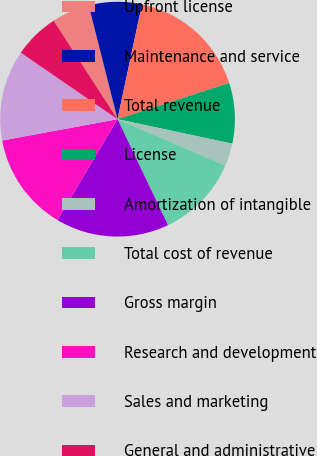<chart> <loc_0><loc_0><loc_500><loc_500><pie_chart><fcel>Upfront license<fcel>Maintenance and service<fcel>Total revenue<fcel>License<fcel>Amortization of intangible<fcel>Total cost of revenue<fcel>Gross margin<fcel>Research and development<fcel>Sales and marketing<fcel>General and administrative<nl><fcel>5.21%<fcel>7.29%<fcel>16.67%<fcel>8.33%<fcel>3.13%<fcel>11.46%<fcel>15.62%<fcel>13.54%<fcel>12.5%<fcel>6.25%<nl></chart> 